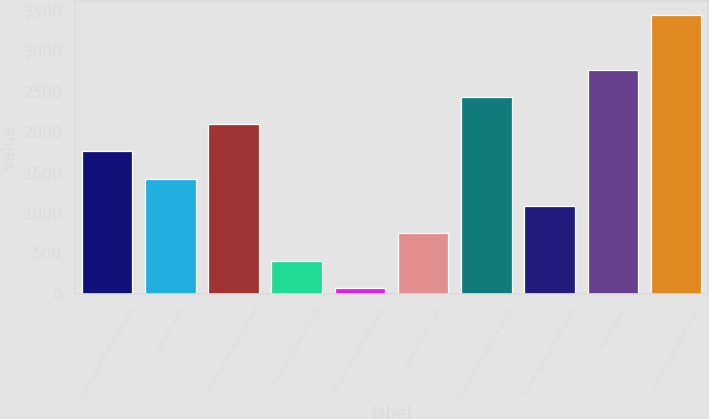<chart> <loc_0><loc_0><loc_500><loc_500><bar_chart><fcel>License and asset acquisition<fcel>Site exit costs<fcel>Research and development<fcel>Provision for restructuring<fcel>Pension and postretirement<fcel>Other income (net)<fcel>Increase/(decrease) to pretax<fcel>Income taxes on items above<fcel>Income taxes<fcel>Increase/(decrease) to net<nl><fcel>1761<fcel>1423<fcel>2099<fcel>409<fcel>71<fcel>747<fcel>2437<fcel>1085<fcel>2775<fcel>3451<nl></chart> 